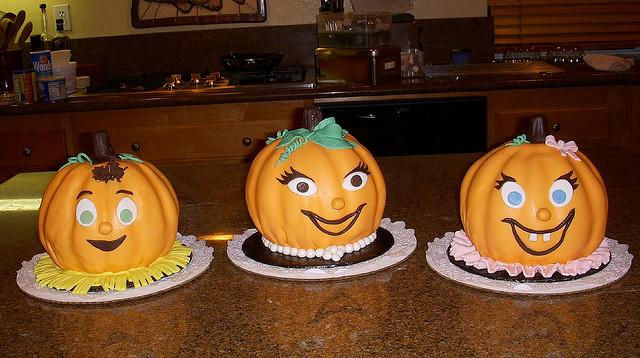Are these happy reflections in the design?
Keep it brief. Yes. What holiday are the cakes celebrating?
Concise answer only. Halloween. Is one design a scarecrow?
Quick response, please. Yes. 